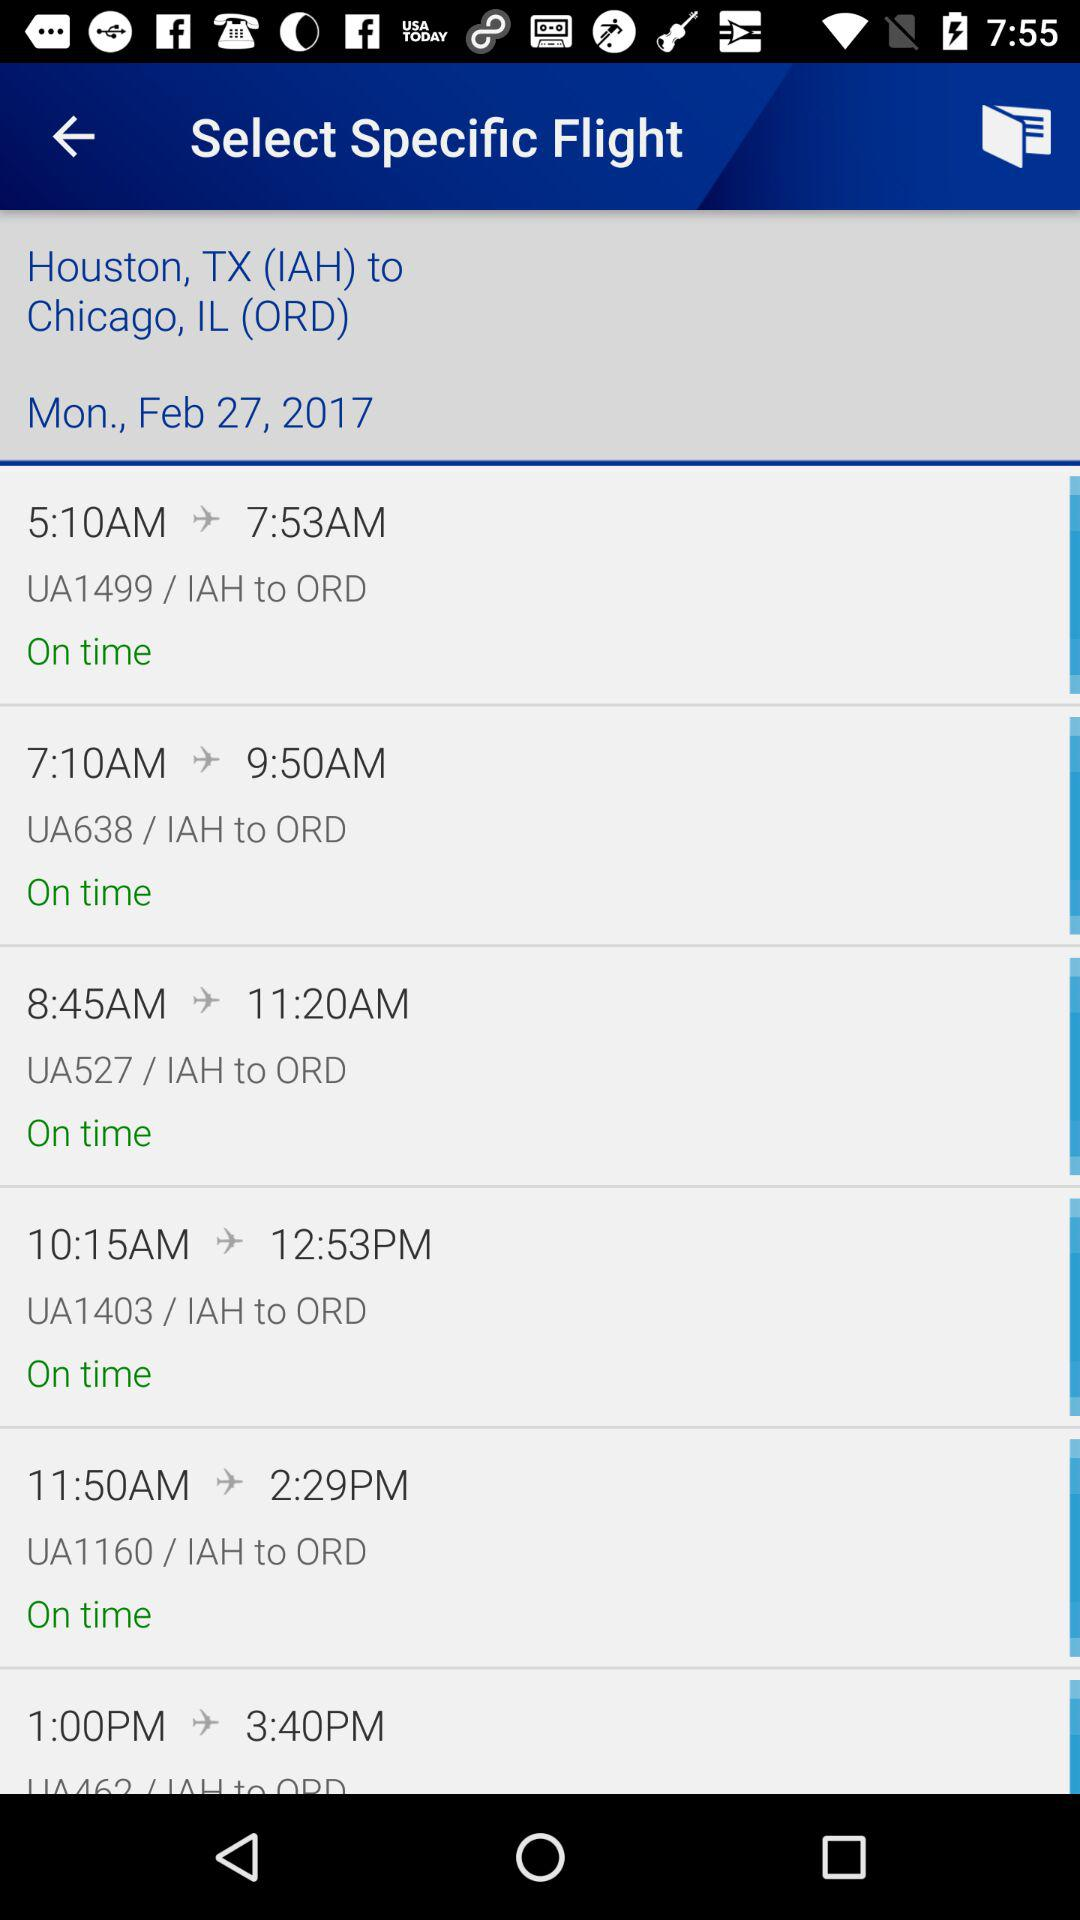What is the departure time of the flight "UA527"? The departure time is 8:45 AM. 